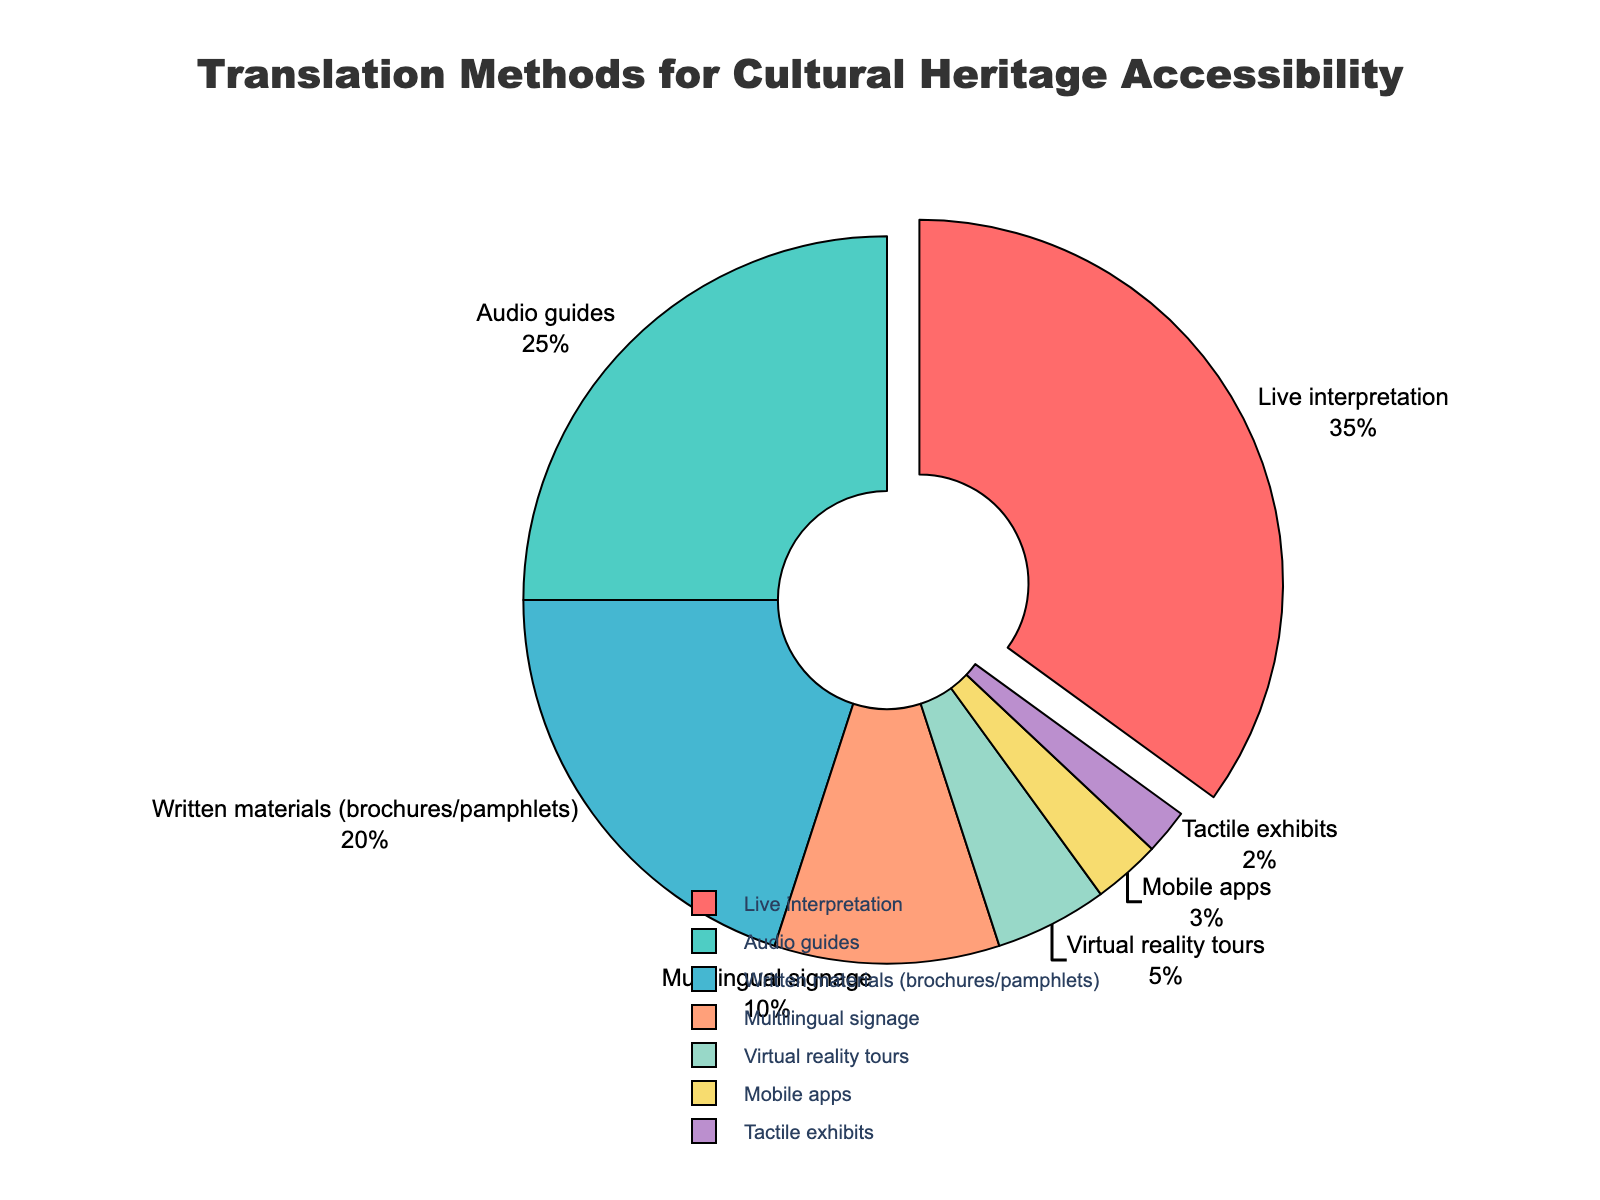What percentage is used for live interpretation and audio guides combined? Add the percentage of live interpretation (35) to that of audio guides (25). 35 + 25 = 60
Answer: 60 Which translation method has the smallest percentage? Tactile exhibits have the smallest percentage directly visible on the pie chart as 2%
Answer: Tactile exhibits How much more popular are audio guides compared to mobile apps in percentage? Subtract the percentage of mobile apps (3) from that of audio guides (25). 25 - 3 = 22
Answer: 22 What is the difference between the percentage of written materials and multilingual signage? Subtract the percentage of multilingual signage (10) from that of written materials (20). 20 - 10 = 10
Answer: 10 Which method uses soft blue color? The color associated with 25% is soft blue, which is used by audio guides
Answer: Audio guides What is the percentage of methods other than live interpretation? Subtract the percentage of live interpretation (35) from 100%. 100 - 35 = 65
Answer: 65 What percentage is attributed to methods involving auditory presentation? Add the percentages of live interpretation (35) and audio guides (25). 35 + 25 = 60
Answer: 60 How do the combined percentages of virtual reality tours and tactile exhibits compare to written materials? Sum the percentages for virtual reality tours (5) and tactile exhibits (2) to get 7, then compare with written materials (20). 20 - 7 = 13
Answer: 13 less Which translation method accounts for more than 20%? Only live interpretation (35) and audio guides (25) account for more than 20%
Answer: Live interpretation, Audio guides 